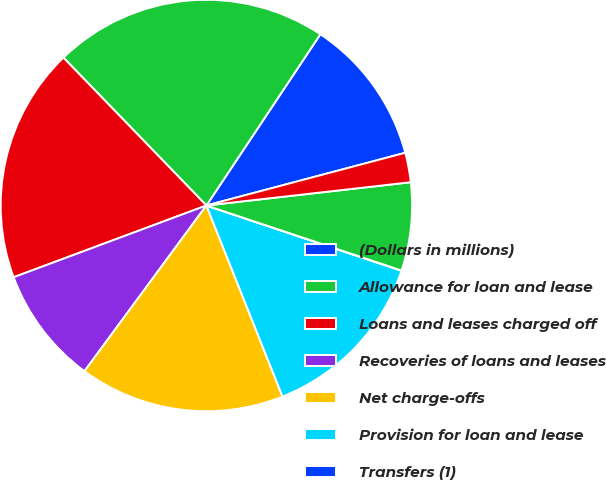Convert chart to OTSL. <chart><loc_0><loc_0><loc_500><loc_500><pie_chart><fcel>(Dollars in millions)<fcel>Allowance for loan and lease<fcel>Loans and leases charged off<fcel>Recoveries of loans and leases<fcel>Net charge-offs<fcel>Provision for loan and lease<fcel>Transfers (1)<fcel>Reserve for unfunded lending<fcel>Provision for unfunded lending<nl><fcel>11.53%<fcel>21.58%<fcel>18.44%<fcel>9.23%<fcel>16.13%<fcel>13.83%<fcel>0.02%<fcel>6.92%<fcel>2.32%<nl></chart> 